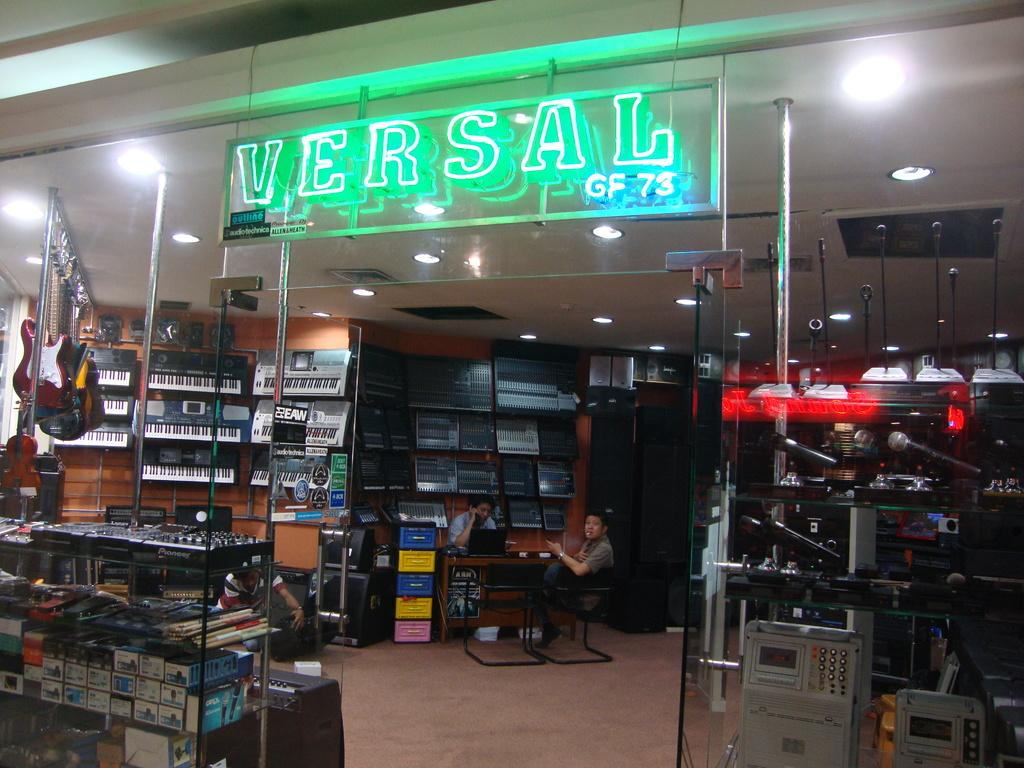<image>
Relay a brief, clear account of the picture shown. A music store with a light up sign reading VERSAL. 